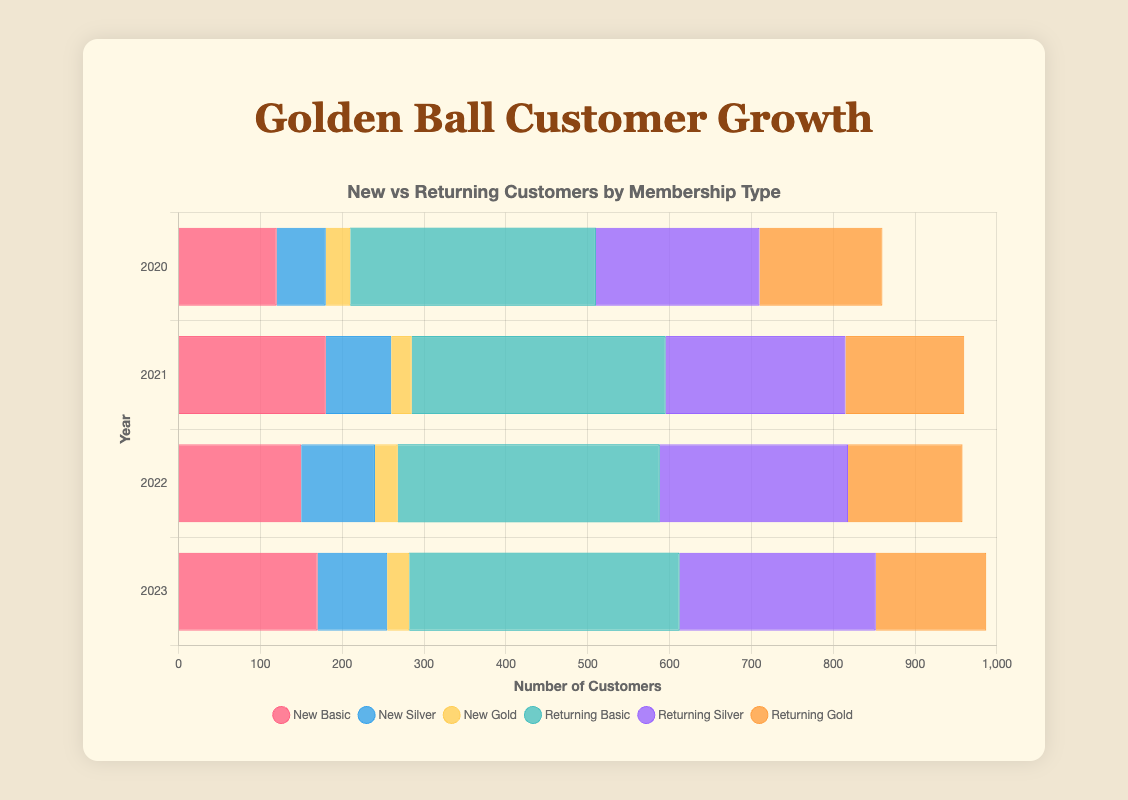What is the total number of new customers with Basic Membership in 2021? The figure shows the number of new Basic Membership customers in each year. For 2021, the number is given directly.
Answer: 180 Which year had the highest number of returning customers with Gold Membership? By examining the lengths of the bars in the 'returning customers' section for Gold Membership across each year, we can identify the year with the longest bar. The bar for 2020 is the longest.
Answer: 2020 What is the average number of new Silver Membership customers from 2020 to 2023? To find the average, sum the numbers of new Silver Membership customers from each year and divide by the number of years. (60 + 80 + 90 + 85 = 315). Divide 315 by 4 to get the average.
Answer: 78.75 Is the number of returning Basic Membership customers in 2023 greater or lesser than in 2020? Compare the lengths of the corresponding bars for returning Basic Membership customers in 2023 and 2020. The 2023 bar is longer, indicating a greater number.
Answer: Greater Which membership type saw a decrease in the number of new customers from 2020 to 2021? By comparing the new customer bars between 2020 and 2021 for each membership type, only the Gold Membership shows a decrease (30 to 25).
Answer: Gold Membership What is the difference between returning Silver Membership customers in 2023 and new Silver Membership customers in 2023? Subtract the number of new Silver Membership customers in 2023 (85) from the number of returning Silver Membership customers in 2023 (240). 240 - 85 = 155.
Answer: 155 Which membership type had the smallest number of new customers in 2022? Identify the shortest bar in the new customer section for 2022. The Gold Membership has the shortest bar with 28 new customers.
Answer: Gold Membership What is the combined total of new customers with Basic Membership and returning customers with Silver Membership in 2022? Sum the new Basic Membership customers (150) and returning Silver Membership customers (230) in 2022. 150 + 230 = 380.
Answer: 380 Which color represents the returning Gold Membership customers in the chart? The color associated with returning Gold Membership customers' bar is visually distinguishable. They are represented with an orange color.
Answer: Orange Has the number of new customers with Silver Membership increased or decreased from 2022 to 2023? Compare the lengths of the bars for new Silver Membership customers in 2022 and 2023. The bar for 2022 is longer, so the number of new Silver Membership customers decreased.
Answer: Decreased 